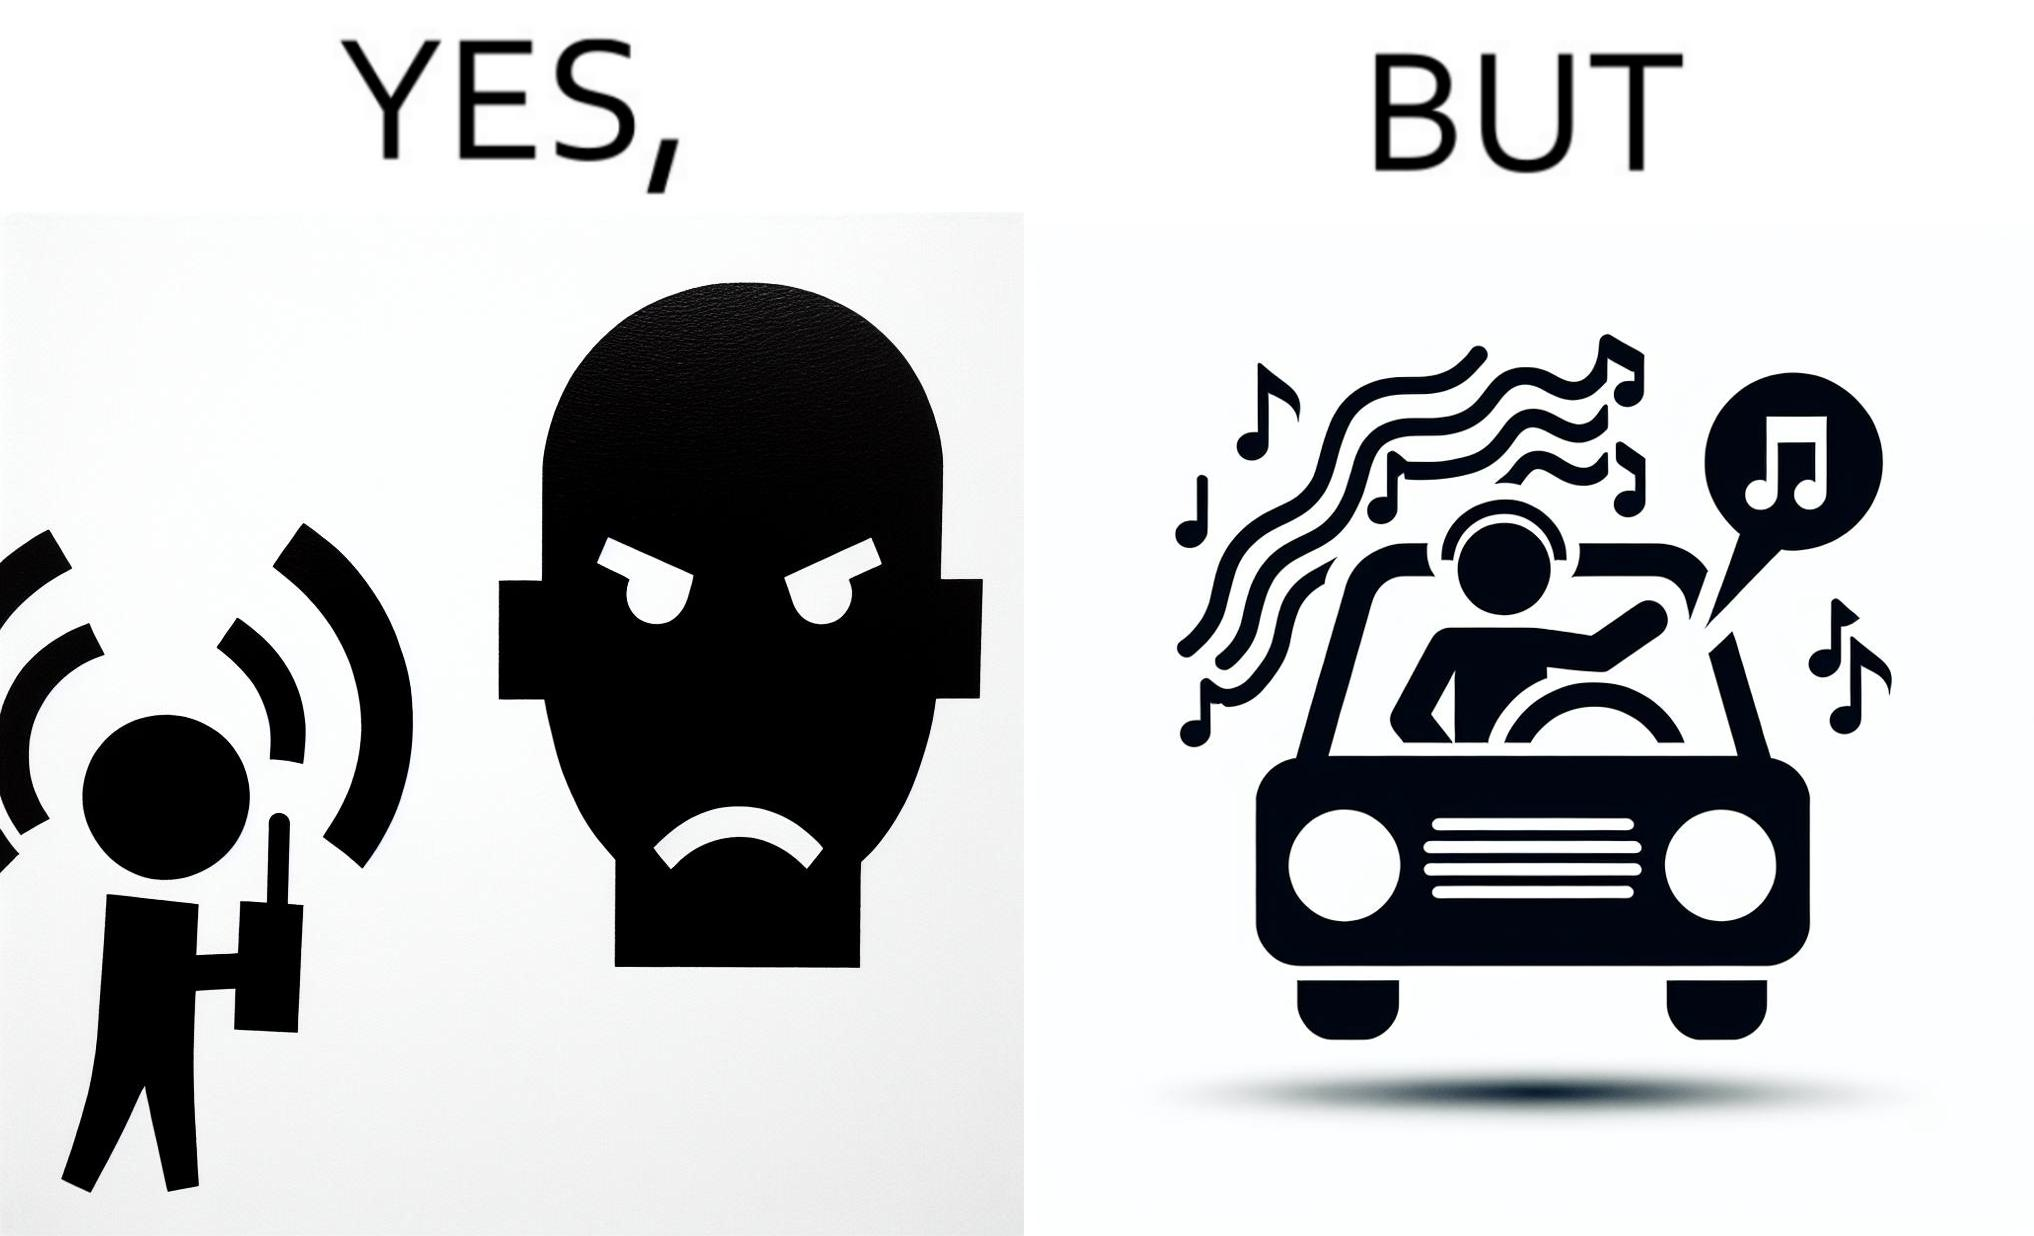Describe the content of this image. The image is funny because while the man does not like the boy playing music loudly on his phone, the man himself is okay with doing the same thing with his car and playing loud music in the car with the sound coming out of the car. 